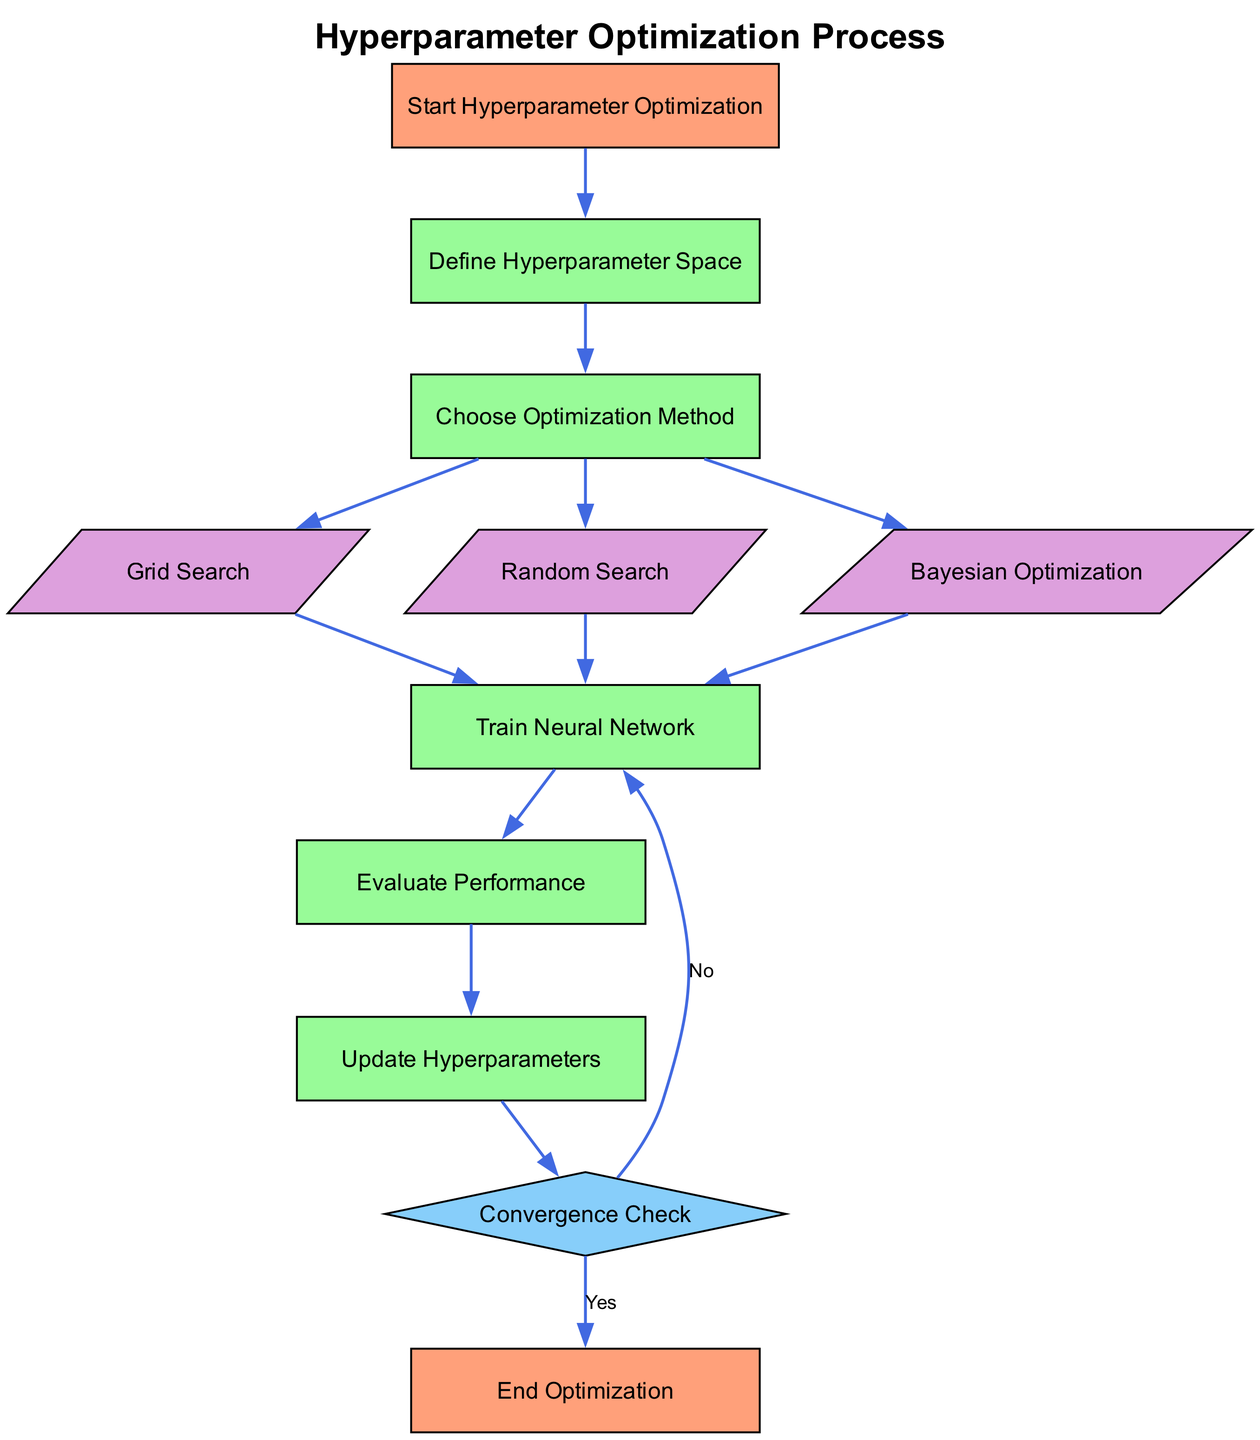What is the first step in the hyperparameter optimization process? The first step indicated in the diagram is "Start Hyperparameter Optimization," which initiates the entire process of optimizing hyperparameters.
Answer: Start Hyperparameter Optimization How many optimization methods are chosen in the flowchart? The diagram shows three distinct optimization methods labeled as Grid Search, Random Search, and Bayesian Optimization. Therefore, the total is three methods.
Answer: Three Which node follows the "Evaluate Performance" node in the flowchart? According to the diagram, after "Evaluate Performance," the next node is "Update Hyperparameters," indicating a sequential relationship in the optimization process.
Answer: Update Hyperparameters What shape is used for the "Convergence Check" node? The "Convergence Check" node is represented as a diamond shape, distinguishing it from other process nodes in the flowchart.
Answer: Diamond If "Grid Search" is selected, what is the next step? After selecting "Grid Search," the next step in the flowchart is to "Train Neural Network," indicating that the chosen method immediately leads to the training phase.
Answer: Train Neural Network What is the final node of the hyperparameter optimization process? The last node in the diagram denotes the endpoint of the optimization process labeled as "End Optimization," signifying the completion of the task.
Answer: End Optimization In the flowchart, what is the relationship between "Update Hyperparameters" and "Convergence Check"? The flowchart illustrates that "Update Hyperparameters" leads directly to "Convergence Check," indicating a directional flow in which updated hyperparameters are checked for convergence afterward.
Answer: Direct flow Which optimization method is depicted first in the diagram? The diagram lists "Grid Search" as the first method under the "Choose Optimization Method" node, thus indicating its sequence in the flowchart.
Answer: Grid Search What occurs if convergence is not achieved? If convergence is not reached, the diagram specifies that the flow returns to the "Train Neural Network" node, allowing for further iterations until convergence is satisfied.
Answer: Train Neural Network 